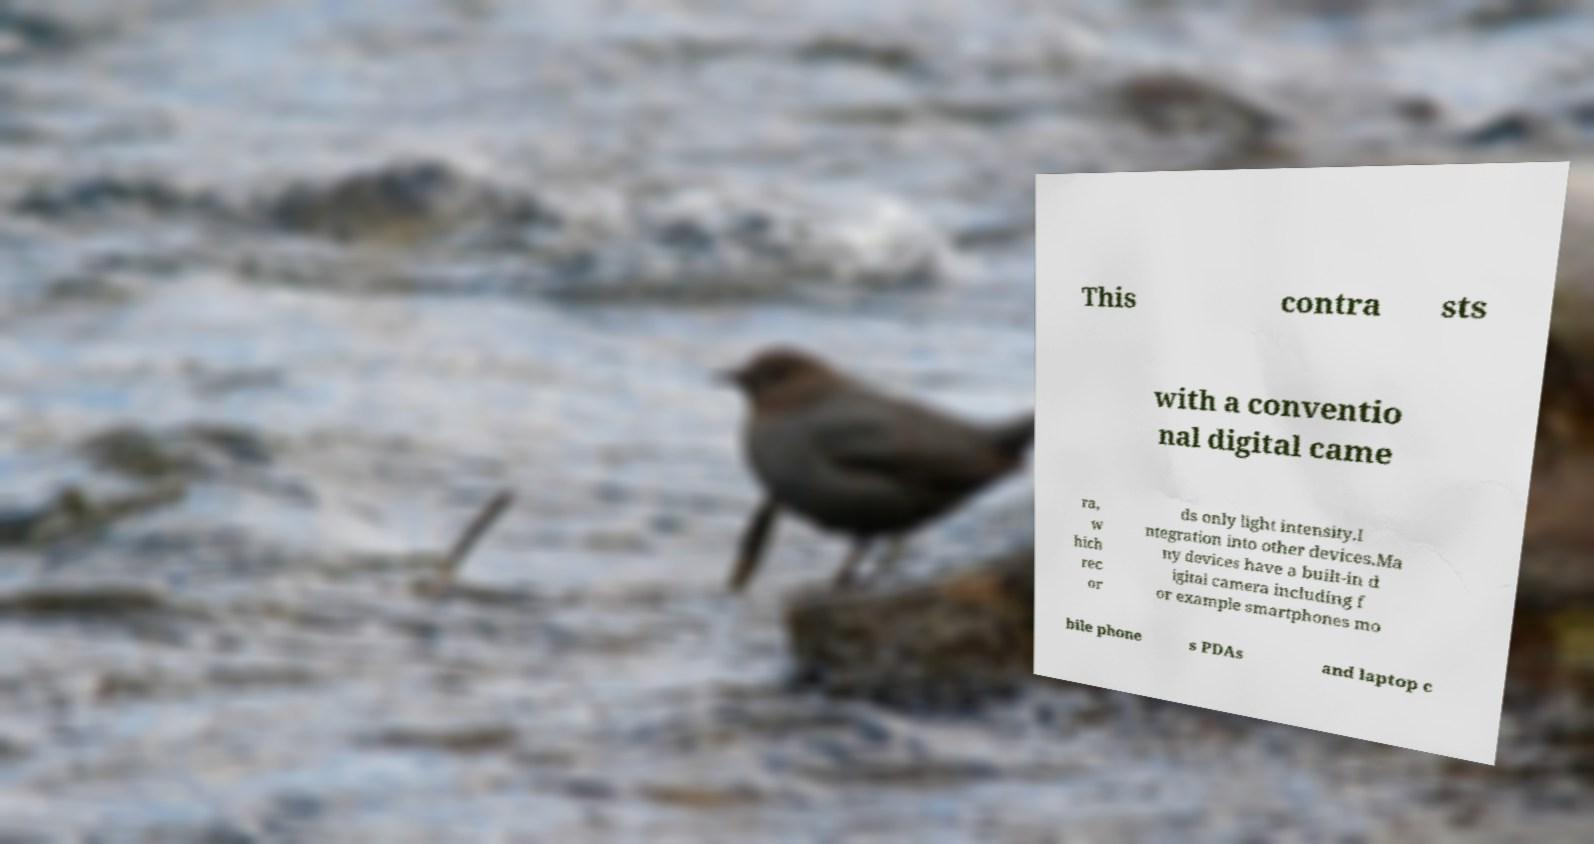Could you assist in decoding the text presented in this image and type it out clearly? This contra sts with a conventio nal digital came ra, w hich rec or ds only light intensity.I ntegration into other devices.Ma ny devices have a built-in d igital camera including f or example smartphones mo bile phone s PDAs and laptop c 